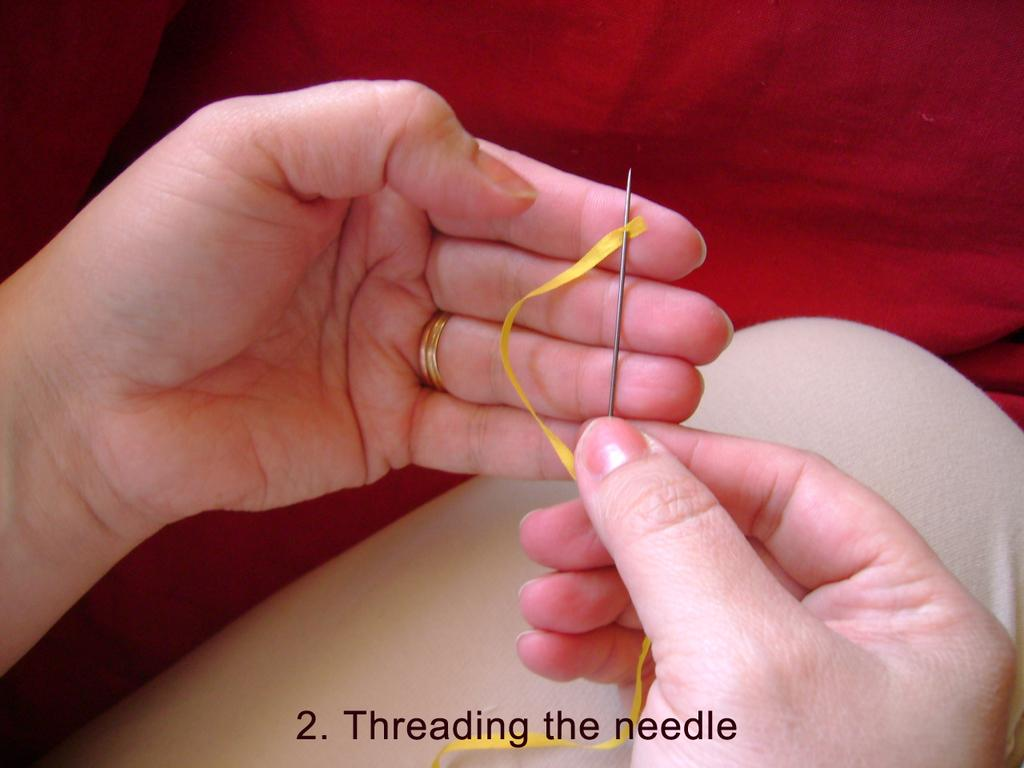What is the main subject of the image? There is a person in the image. What is the person doing in the image? The person is threading a needle. What color is the cloth visible at the top of the image? There is a red color cloth at the top of the image. What can be found at the bottom of the image? There is text at the bottom of the image. How many toes can be seen on the person's feet in the image? There is no visible feet or toes in the image, as the person is focused on threading a needle. What type of trains are passing by in the background of the image? There are no trains present in the image; it only features a person threading a needle and a red cloth. 